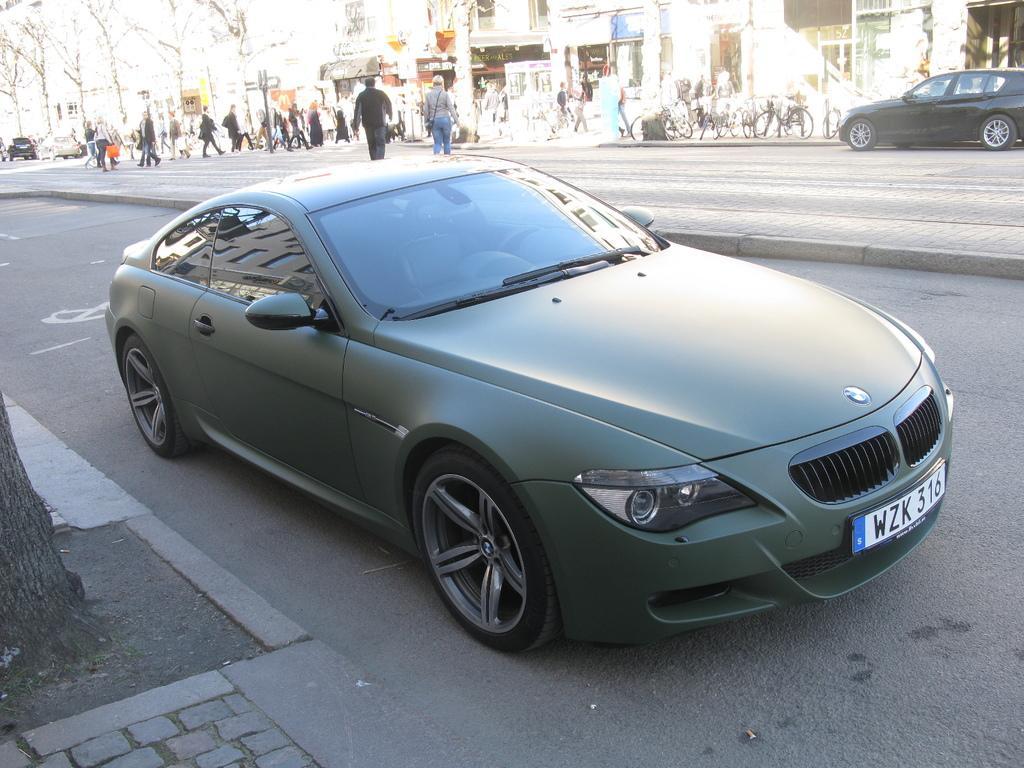Describe this image in one or two sentences. In this image there are vehicle on a road and few people are crossing the road and few are walking on the footpath, in the background there are trees and buildings and cycles. 